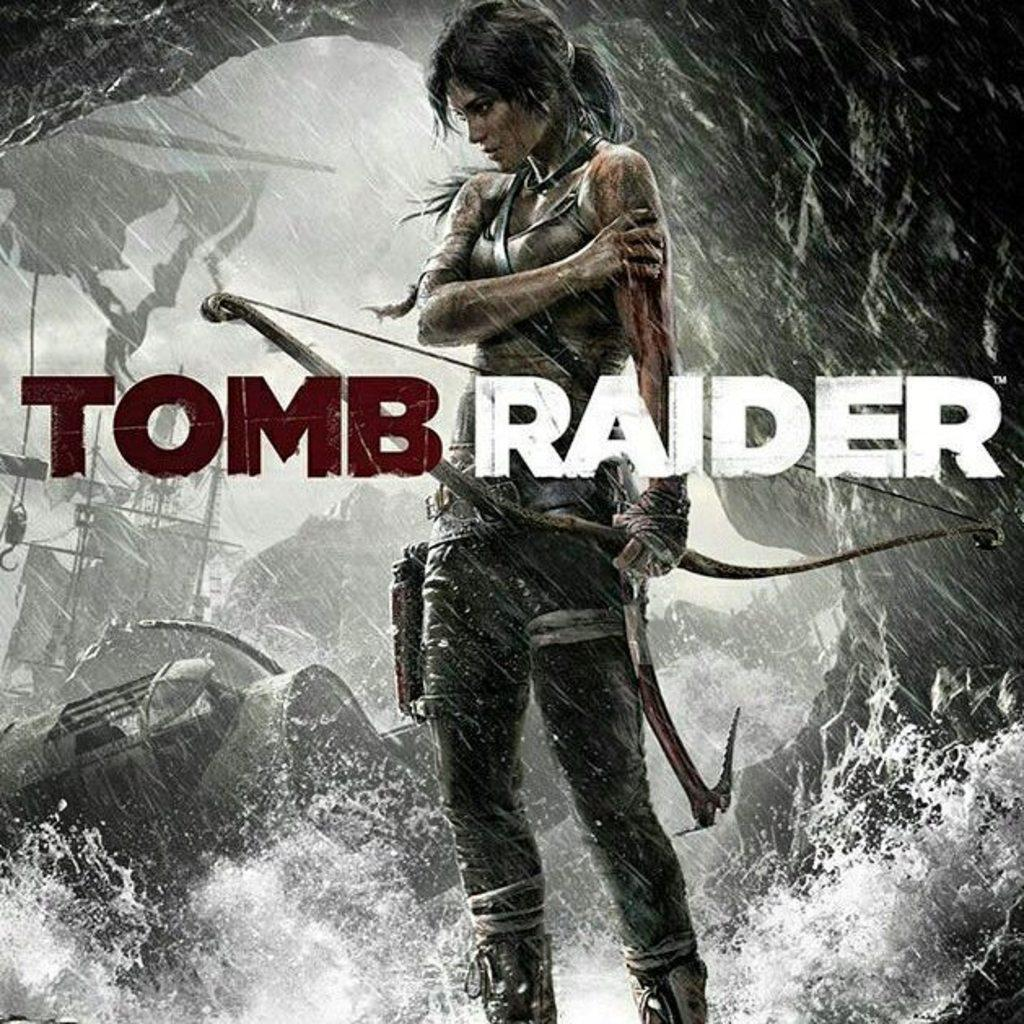<image>
Present a compact description of the photo's key features. A woman stands in the background of text that says, "Tomb Raider". 